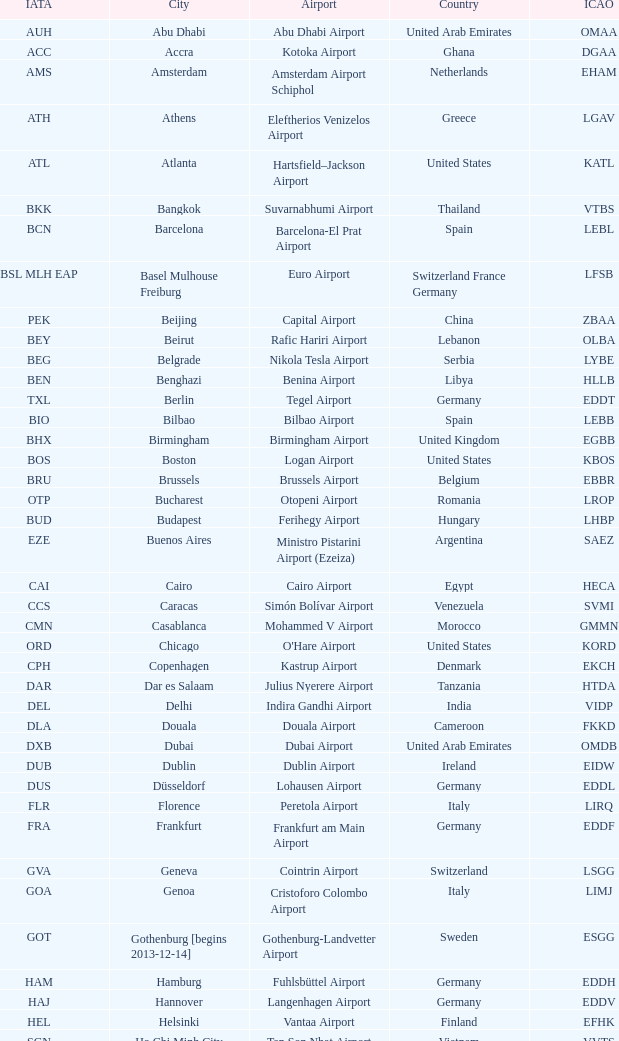What city is fuhlsbüttel airport in? Hamburg. 